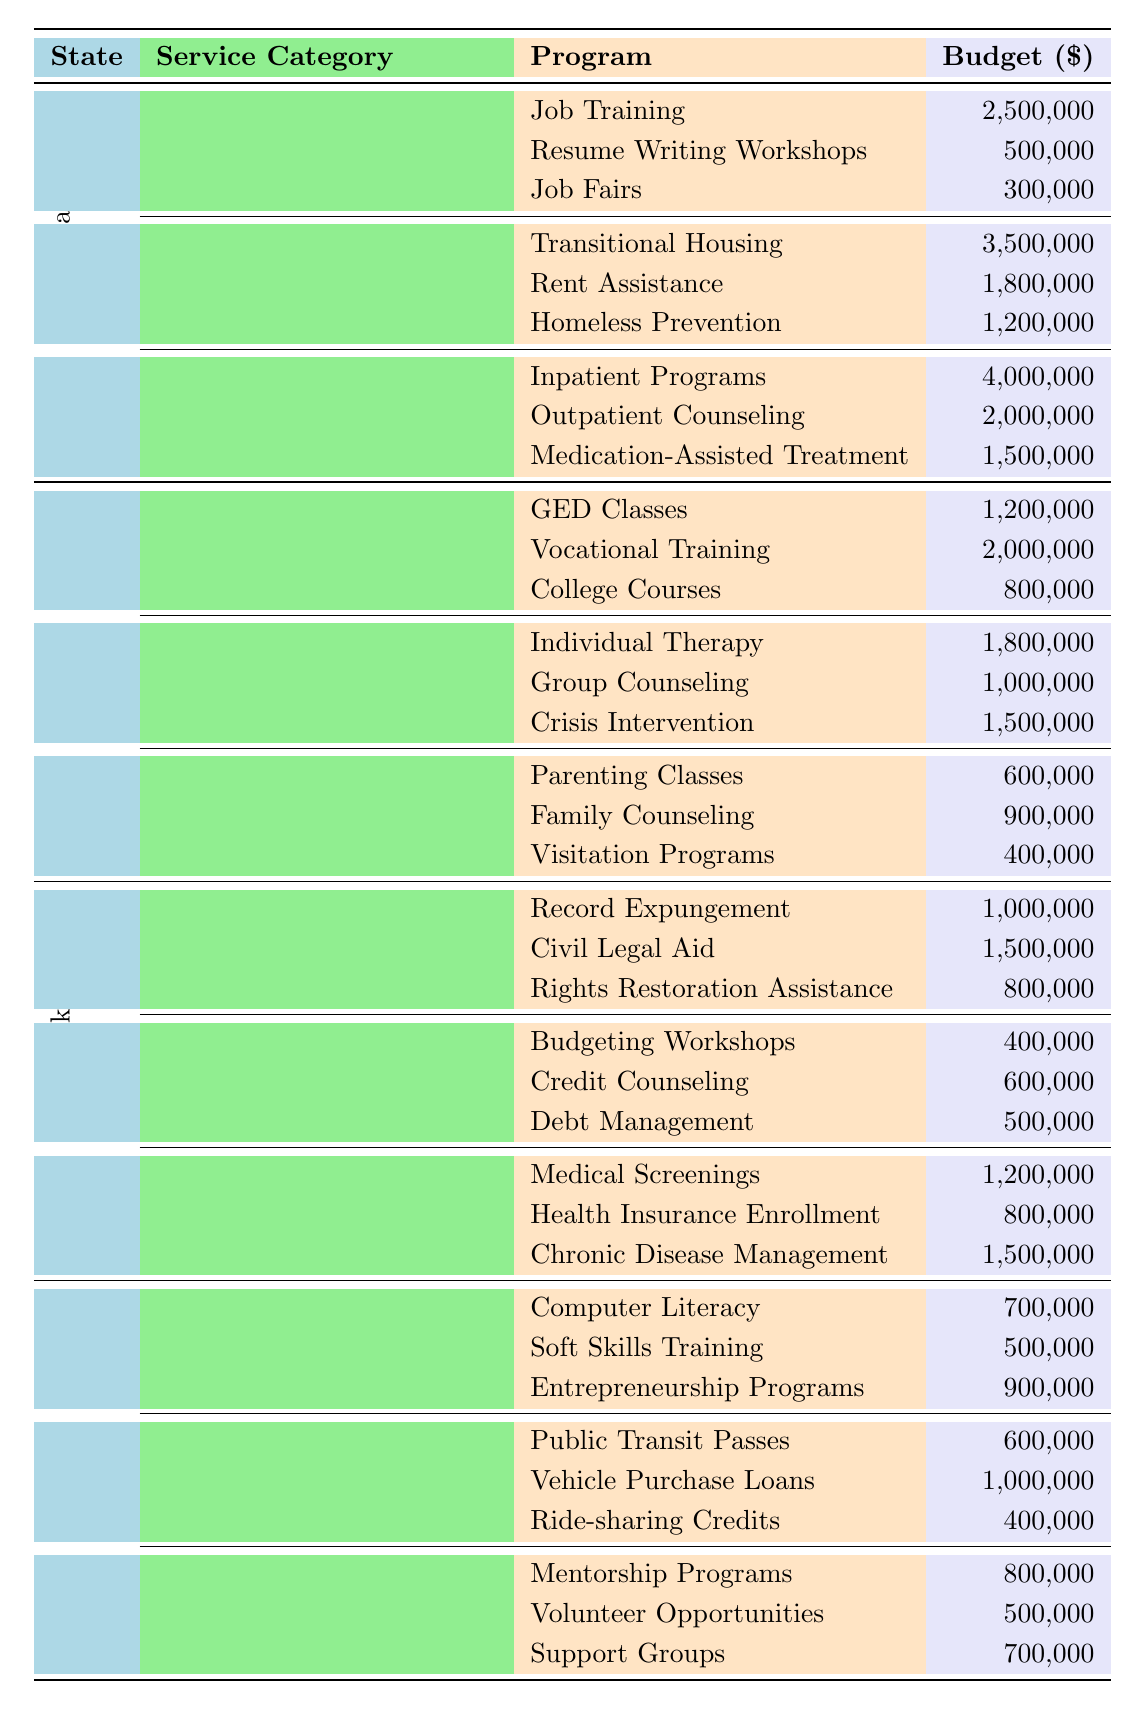What is the total budget allocated for Substance Abuse Treatment in California? To find the total budget for Substance Abuse Treatment, I will sum the individual budgets for Inpatient Programs (4,000,000), Outpatient Counseling (2,000,000), and Medication-Assisted Treatment (1,500,000). The total is calculated as 4,000,000 + 2,000,000 + 1,500,000 = 7,500,000.
Answer: 7,500,000 Which state has the highest budget for Housing Support programs? By reviewing the Housing Support budgets for each state—California (3,500,000 + 1,800,000 + 1,200,000 = 6,500,000), Texas (not applicable), New York (not applicable), and Florida (not applicable)—I see that California's total for Housing Support is 6,500,000, which is the only state with data in this category.
Answer: California Do all states have a program for Family Reunification? Looking at the table, only Texas has specific programs listed under Family Reunification. California, New York, and Florida do not have such a category in their budgets. Therefore, the statement is false.
Answer: False What is the average budget allocated for Employment Assistance programs in California? The Employment Assistance budget includes Job Training (2,500,000), Resume Writing Workshops (500,000), and Job Fairs (300,000). The total budget for this category is 2,500,000 + 500,000 + 300,000 = 3,300,000. The average budget is then calculated by dividing this total by the number of programs (3), which gives 3,300,000 / 3 = 1,100,000.
Answer: 1,100,000 Which program category has the smallest total budget in Texas? To find this, I need to calculate the total budgets for each category in Texas: Education Programs (1,200,000 + 2,000,000 + 800,000 = 4,000,000), Mental Health Services (1,800,000 + 1,000,000 + 1,500,000 = 4,300,000), and Family Reunification (600,000 + 900,000 + 400,000 = 1,900,000). The smallest total is for Family Reunification, with a total budget of 1,900,000.
Answer: Family Reunification What is the combined budget for Healthcare Access programs in New York? The combined budget for the Healthcare Access category includes Medical Screenings (1,200,000), Health Insurance Enrollment (800,000), and Chronic Disease Management (1,500,000). Adding these gives 1,200,000 + 800,000 + 1,500,000 = 3,500,000 for Healthcare Access in New York.
Answer: 3,500,000 Which state has a budget for Transportation Assistance and what is its total? Florida has a budget for Transportation Assistance with three programs. To find the total, I’ll sum Public Transit Passes (600,000), Vehicle Purchase Loans (1,000,000), and Ride-sharing Credits (400,000). The total is 600,000 + 1,000,000 + 400,000 = 2,000,000.
Answer: Florida, 2,000,000 